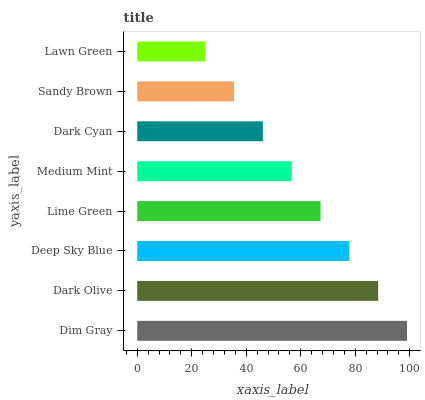Is Lawn Green the minimum?
Answer yes or no. Yes. Is Dim Gray the maximum?
Answer yes or no. Yes. Is Dark Olive the minimum?
Answer yes or no. No. Is Dark Olive the maximum?
Answer yes or no. No. Is Dim Gray greater than Dark Olive?
Answer yes or no. Yes. Is Dark Olive less than Dim Gray?
Answer yes or no. Yes. Is Dark Olive greater than Dim Gray?
Answer yes or no. No. Is Dim Gray less than Dark Olive?
Answer yes or no. No. Is Lime Green the high median?
Answer yes or no. Yes. Is Medium Mint the low median?
Answer yes or no. Yes. Is Medium Mint the high median?
Answer yes or no. No. Is Dim Gray the low median?
Answer yes or no. No. 